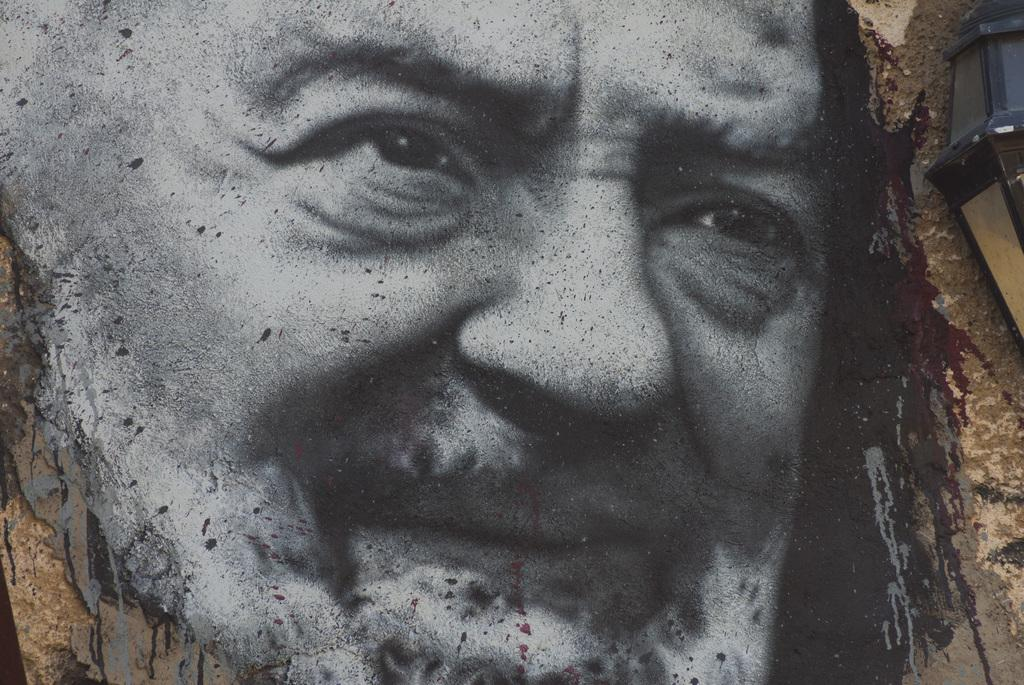What is depicted in the image? There is a painting of a person in the image. Can you describe the subject of the painting? The painting features a person, but no specific details about the person's appearance or actions are provided. What type of wine is being served on the seashore in the image? There is no wine or seashore present in the image; it only features a painting of a person. 